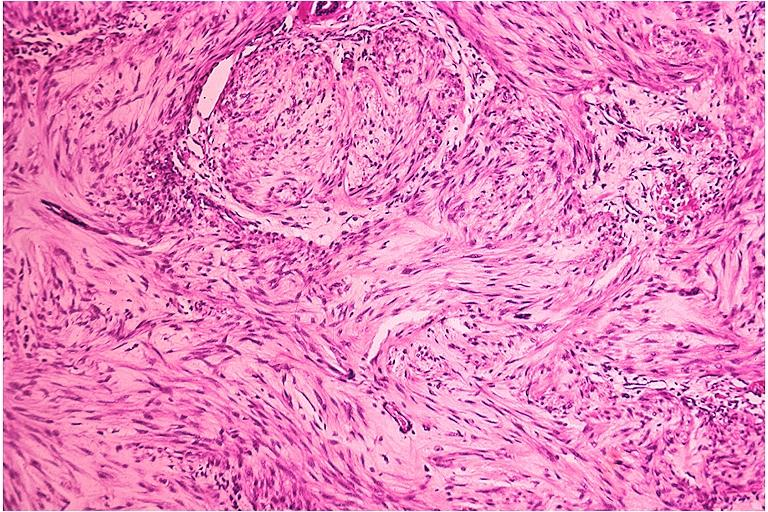what is present?
Answer the question using a single word or phrase. Oral 